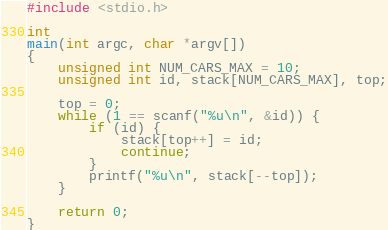<code> <loc_0><loc_0><loc_500><loc_500><_C_>#include <stdio.h>

int
main(int argc, char *argv[])
{
    unsigned int NUM_CARS_MAX = 10;
    unsigned int id, stack[NUM_CARS_MAX], top;

    top = 0;
    while (1 == scanf("%u\n", &id)) {
        if (id) {
            stack[top++] = id;
            continue;
        }
        printf("%u\n", stack[--top]);
    }

    return 0;
}</code> 